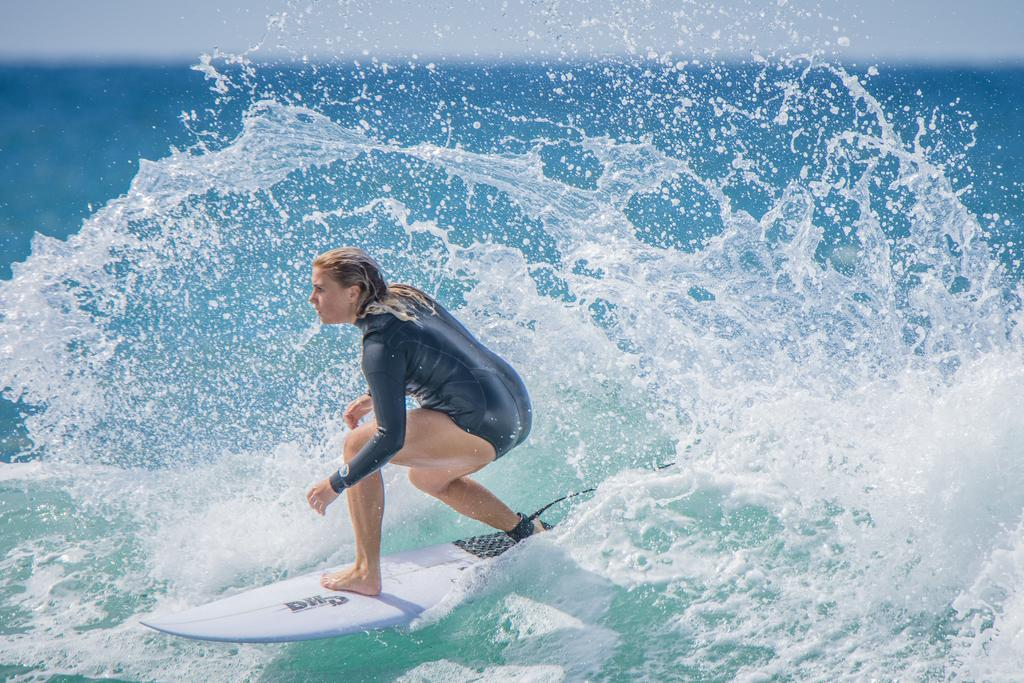Who is the main subject in the image? There is a woman in the image. What is the woman doing in the image? The woman is surfing on the water. What can be seen in the background of the image? The water is visible in the image. What type of pen is the woman using to write her name on the water? There is no pen present in the image, and the woman is surfing, not writing her name on the water. 